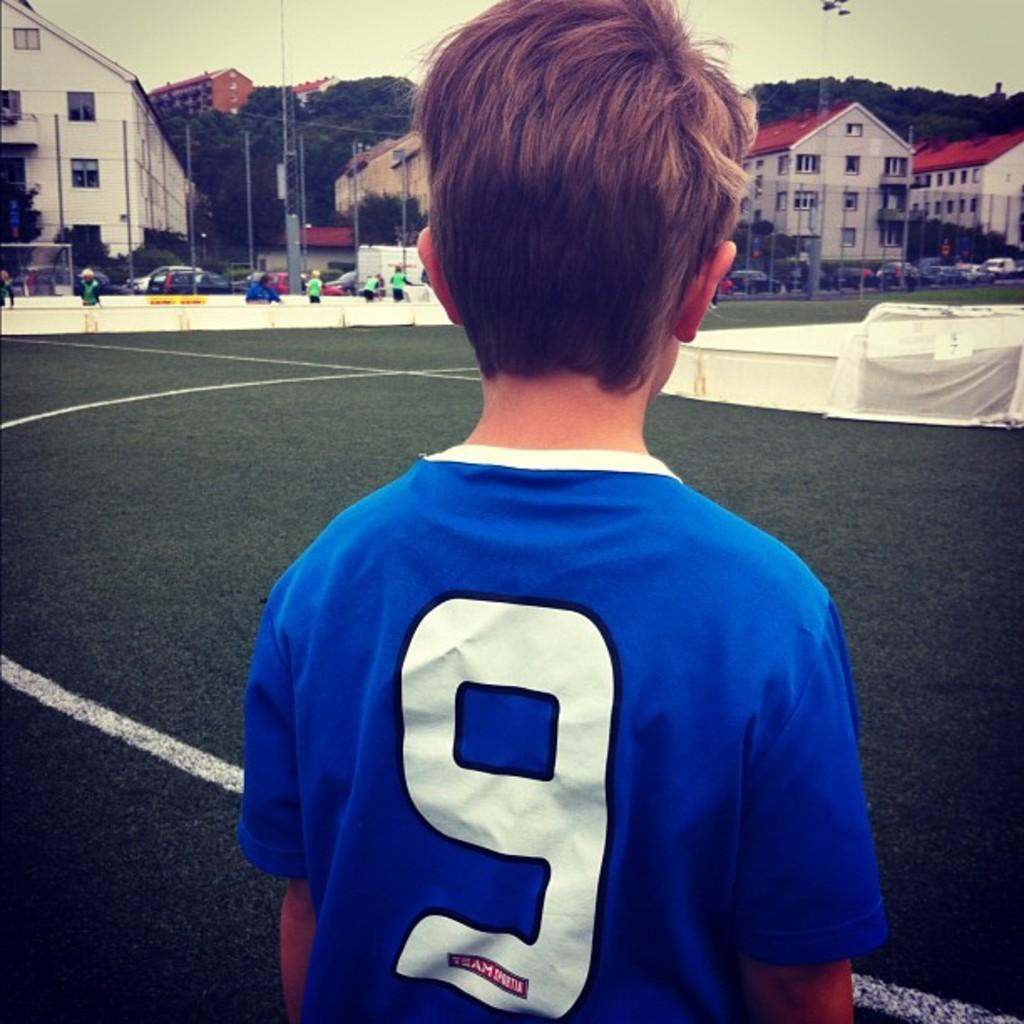What number is the kid?
Your response must be concise. 9. 